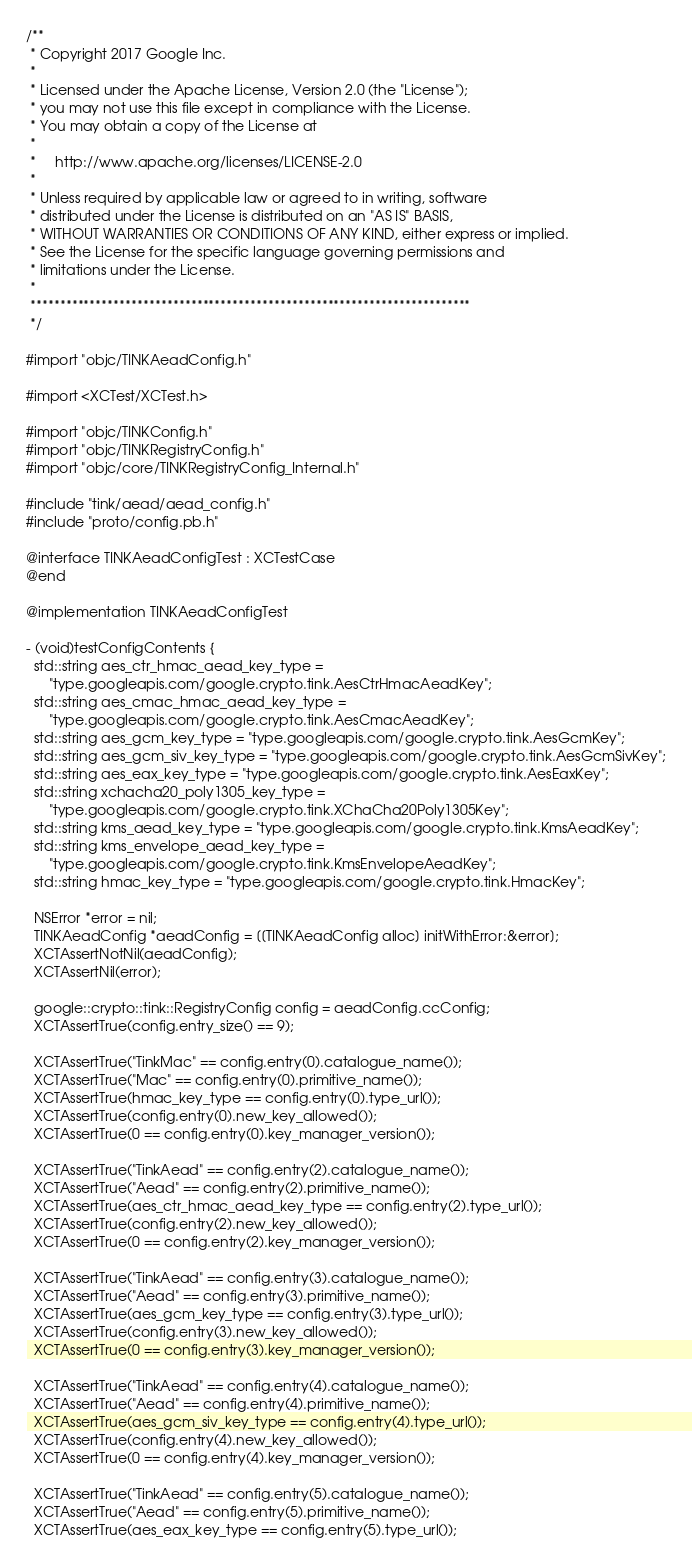Convert code to text. <code><loc_0><loc_0><loc_500><loc_500><_ObjectiveC_>/**
 * Copyright 2017 Google Inc.
 *
 * Licensed under the Apache License, Version 2.0 (the "License");
 * you may not use this file except in compliance with the License.
 * You may obtain a copy of the License at
 *
 *     http://www.apache.org/licenses/LICENSE-2.0
 *
 * Unless required by applicable law or agreed to in writing, software
 * distributed under the License is distributed on an "AS IS" BASIS,
 * WITHOUT WARRANTIES OR CONDITIONS OF ANY KIND, either express or implied.
 * See the License for the specific language governing permissions and
 * limitations under the License.
 *
 **************************************************************************
 */

#import "objc/TINKAeadConfig.h"

#import <XCTest/XCTest.h>

#import "objc/TINKConfig.h"
#import "objc/TINKRegistryConfig.h"
#import "objc/core/TINKRegistryConfig_Internal.h"

#include "tink/aead/aead_config.h"
#include "proto/config.pb.h"

@interface TINKAeadConfigTest : XCTestCase
@end

@implementation TINKAeadConfigTest

- (void)testConfigContents {
  std::string aes_ctr_hmac_aead_key_type =
      "type.googleapis.com/google.crypto.tink.AesCtrHmacAeadKey";
  std::string aes_cmac_hmac_aead_key_type =
      "type.googleapis.com/google.crypto.tink.AesCmacAeadKey";
  std::string aes_gcm_key_type = "type.googleapis.com/google.crypto.tink.AesGcmKey";
  std::string aes_gcm_siv_key_type = "type.googleapis.com/google.crypto.tink.AesGcmSivKey";
  std::string aes_eax_key_type = "type.googleapis.com/google.crypto.tink.AesEaxKey";
  std::string xchacha20_poly1305_key_type =
      "type.googleapis.com/google.crypto.tink.XChaCha20Poly1305Key";
  std::string kms_aead_key_type = "type.googleapis.com/google.crypto.tink.KmsAeadKey";
  std::string kms_envelope_aead_key_type =
      "type.googleapis.com/google.crypto.tink.KmsEnvelopeAeadKey";
  std::string hmac_key_type = "type.googleapis.com/google.crypto.tink.HmacKey";

  NSError *error = nil;
  TINKAeadConfig *aeadConfig = [[TINKAeadConfig alloc] initWithError:&error];
  XCTAssertNotNil(aeadConfig);
  XCTAssertNil(error);

  google::crypto::tink::RegistryConfig config = aeadConfig.ccConfig;
  XCTAssertTrue(config.entry_size() == 9);

  XCTAssertTrue("TinkMac" == config.entry(0).catalogue_name());
  XCTAssertTrue("Mac" == config.entry(0).primitive_name());
  XCTAssertTrue(hmac_key_type == config.entry(0).type_url());
  XCTAssertTrue(config.entry(0).new_key_allowed());
  XCTAssertTrue(0 == config.entry(0).key_manager_version());

  XCTAssertTrue("TinkAead" == config.entry(2).catalogue_name());
  XCTAssertTrue("Aead" == config.entry(2).primitive_name());
  XCTAssertTrue(aes_ctr_hmac_aead_key_type == config.entry(2).type_url());
  XCTAssertTrue(config.entry(2).new_key_allowed());
  XCTAssertTrue(0 == config.entry(2).key_manager_version());

  XCTAssertTrue("TinkAead" == config.entry(3).catalogue_name());
  XCTAssertTrue("Aead" == config.entry(3).primitive_name());
  XCTAssertTrue(aes_gcm_key_type == config.entry(3).type_url());
  XCTAssertTrue(config.entry(3).new_key_allowed());
  XCTAssertTrue(0 == config.entry(3).key_manager_version());

  XCTAssertTrue("TinkAead" == config.entry(4).catalogue_name());
  XCTAssertTrue("Aead" == config.entry(4).primitive_name());
  XCTAssertTrue(aes_gcm_siv_key_type == config.entry(4).type_url());
  XCTAssertTrue(config.entry(4).new_key_allowed());
  XCTAssertTrue(0 == config.entry(4).key_manager_version());

  XCTAssertTrue("TinkAead" == config.entry(5).catalogue_name());
  XCTAssertTrue("Aead" == config.entry(5).primitive_name());
  XCTAssertTrue(aes_eax_key_type == config.entry(5).type_url());</code> 